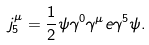<formula> <loc_0><loc_0><loc_500><loc_500>j _ { 5 } ^ { \mu } = \frac { 1 } { 2 } \psi \gamma ^ { 0 } \gamma ^ { \mu } e \gamma ^ { 5 } \psi .</formula> 